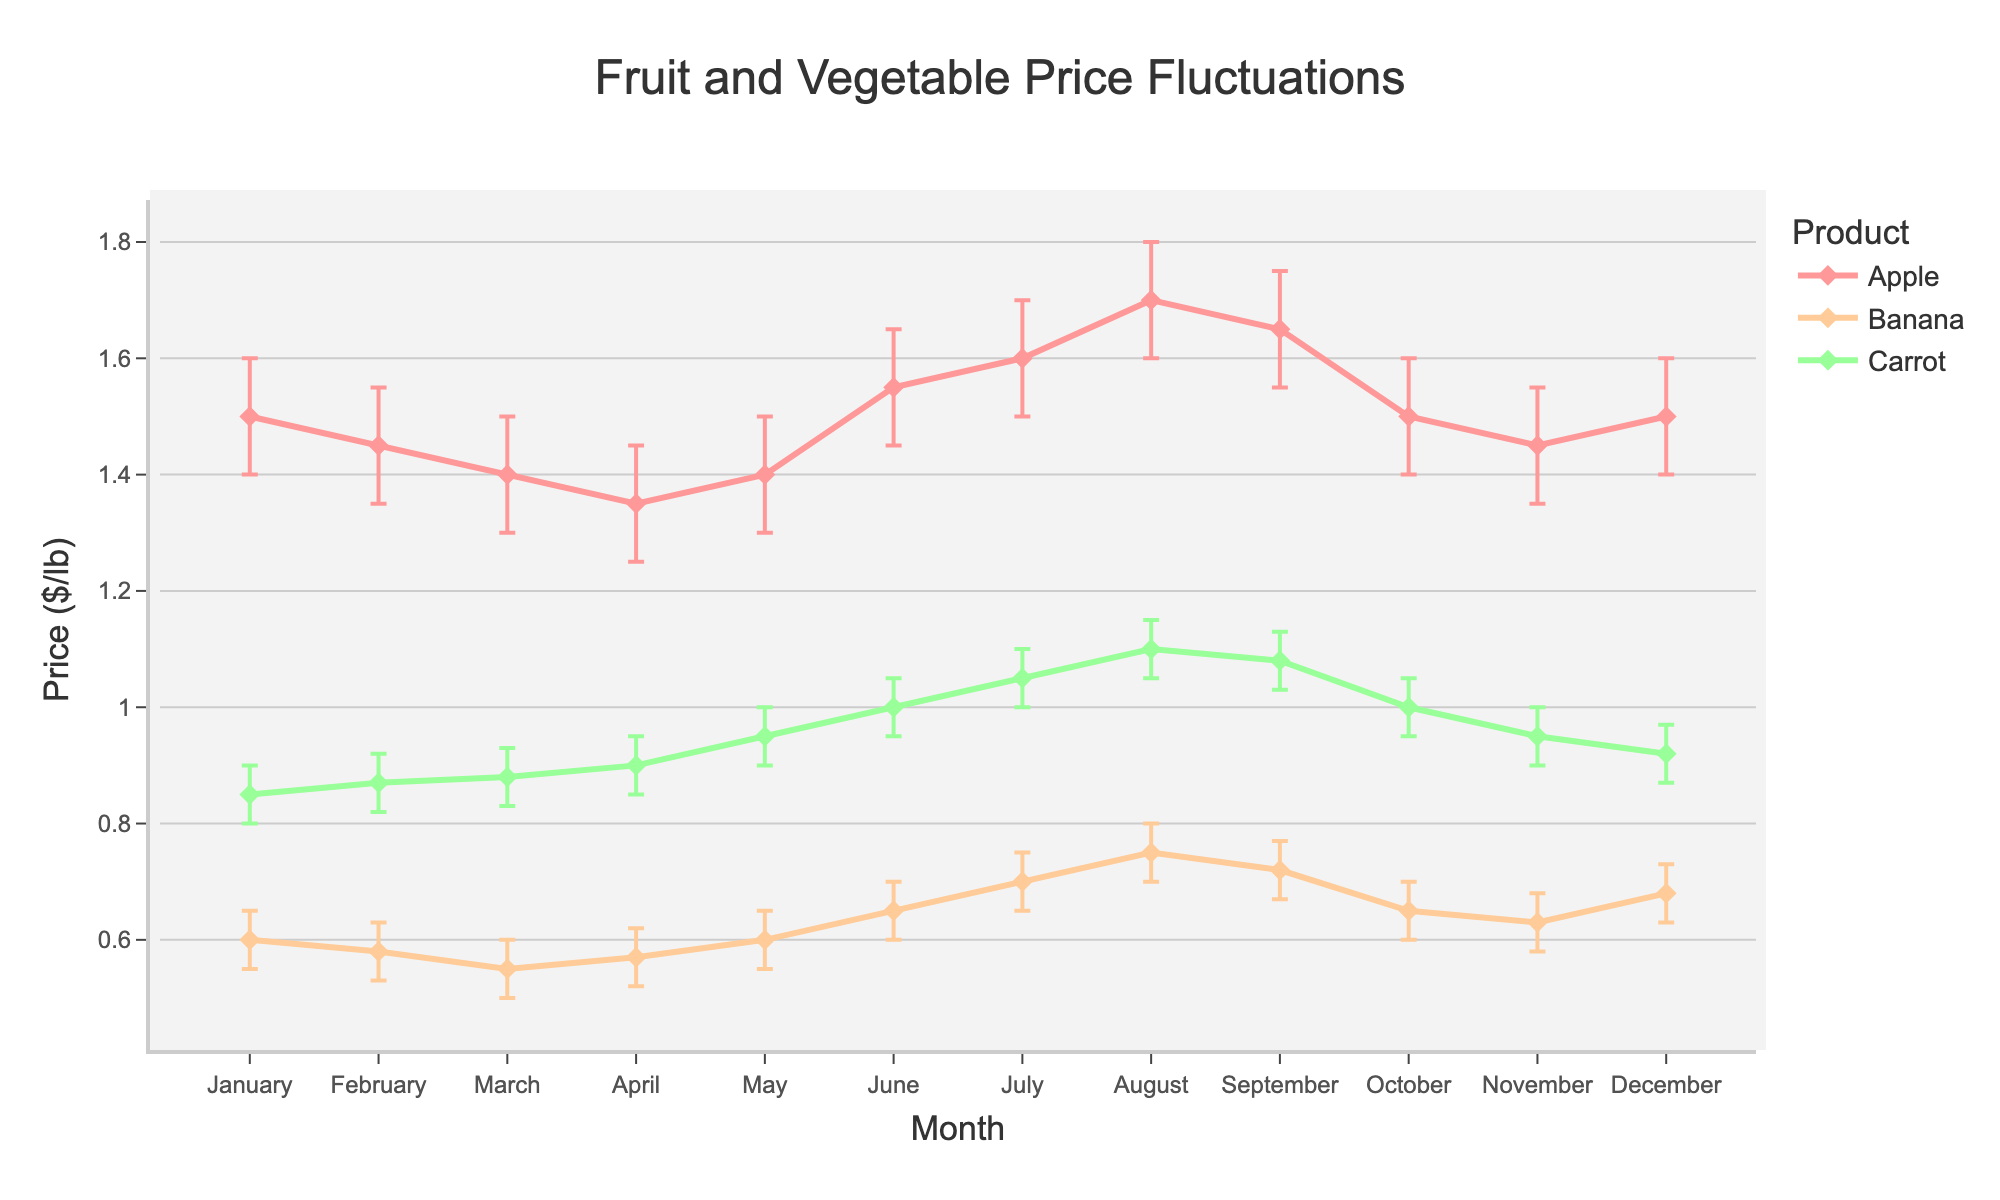What is the title of the figure? The title is usually found at the top of the figure and summarizes the content. In this case, it will clearly indicate what the plot is showing.
Answer: Fruit and Vegetable Price Fluctuations What are the products being tracked in the figure? We can identify the products by looking at the legend on the plot, which indicates which line corresponds to which product.
Answer: Apple, Banana, Carrot What is the price range for apples throughout the year? To find the price range, we need to look at the highest and lowest points in the error bars for apples. Identify the peak upper confidence interval and the lowest lower confidence interval.
Answer: $1.25 to $1.80 per lb In which month does banana have the highest mean price? We need to follow the line for bananas and find the month corresponding to the highest point on that line.
Answer: August What is the average mean price of carrots over the year? Add up the monthly mean prices of carrots and divide by 12 (number of months). (0.85 + 0.87 + 0.88 + 0.90 + 0.95 + 1.00 + 1.05 + 1.10 + 1.08 + 1.00 + 0.95 + 0.92) / 12
Answer: $0.96 per lb Which product shows the most significant price fluctuation over the year? This is determined by looking at which product has the largest difference between its highest and lowest mean prices within the plot.
Answer: Apple During which month is the price range (difference between the upper and lower confidence intervals) for carrots the smallest? We need to look at the error bars for carrots and find the shortest gap between upper and lower confidence intervals. Check month by month.
Answer: January Compare the price trends of apples and bananas in the first half of the year. Which one generally increases in price? Examine the lines for both apples and bananas from January to June. Determine which one shows a general upward trend in this period.
Answer: Banana What is the general trend for the price of carrots from June to December? Analyze the line for carrots from June to December to see if it is moving upwards, downwards, or staying relatively flat.
Answer: Downward trend In which month do all three products (Apple, Banana, Carrot) have their mean prices closest to each other? Identify the points where the lines for apples, bananas, and carrots converge most closely together. Calculate the price differences if needed.
Answer: May 